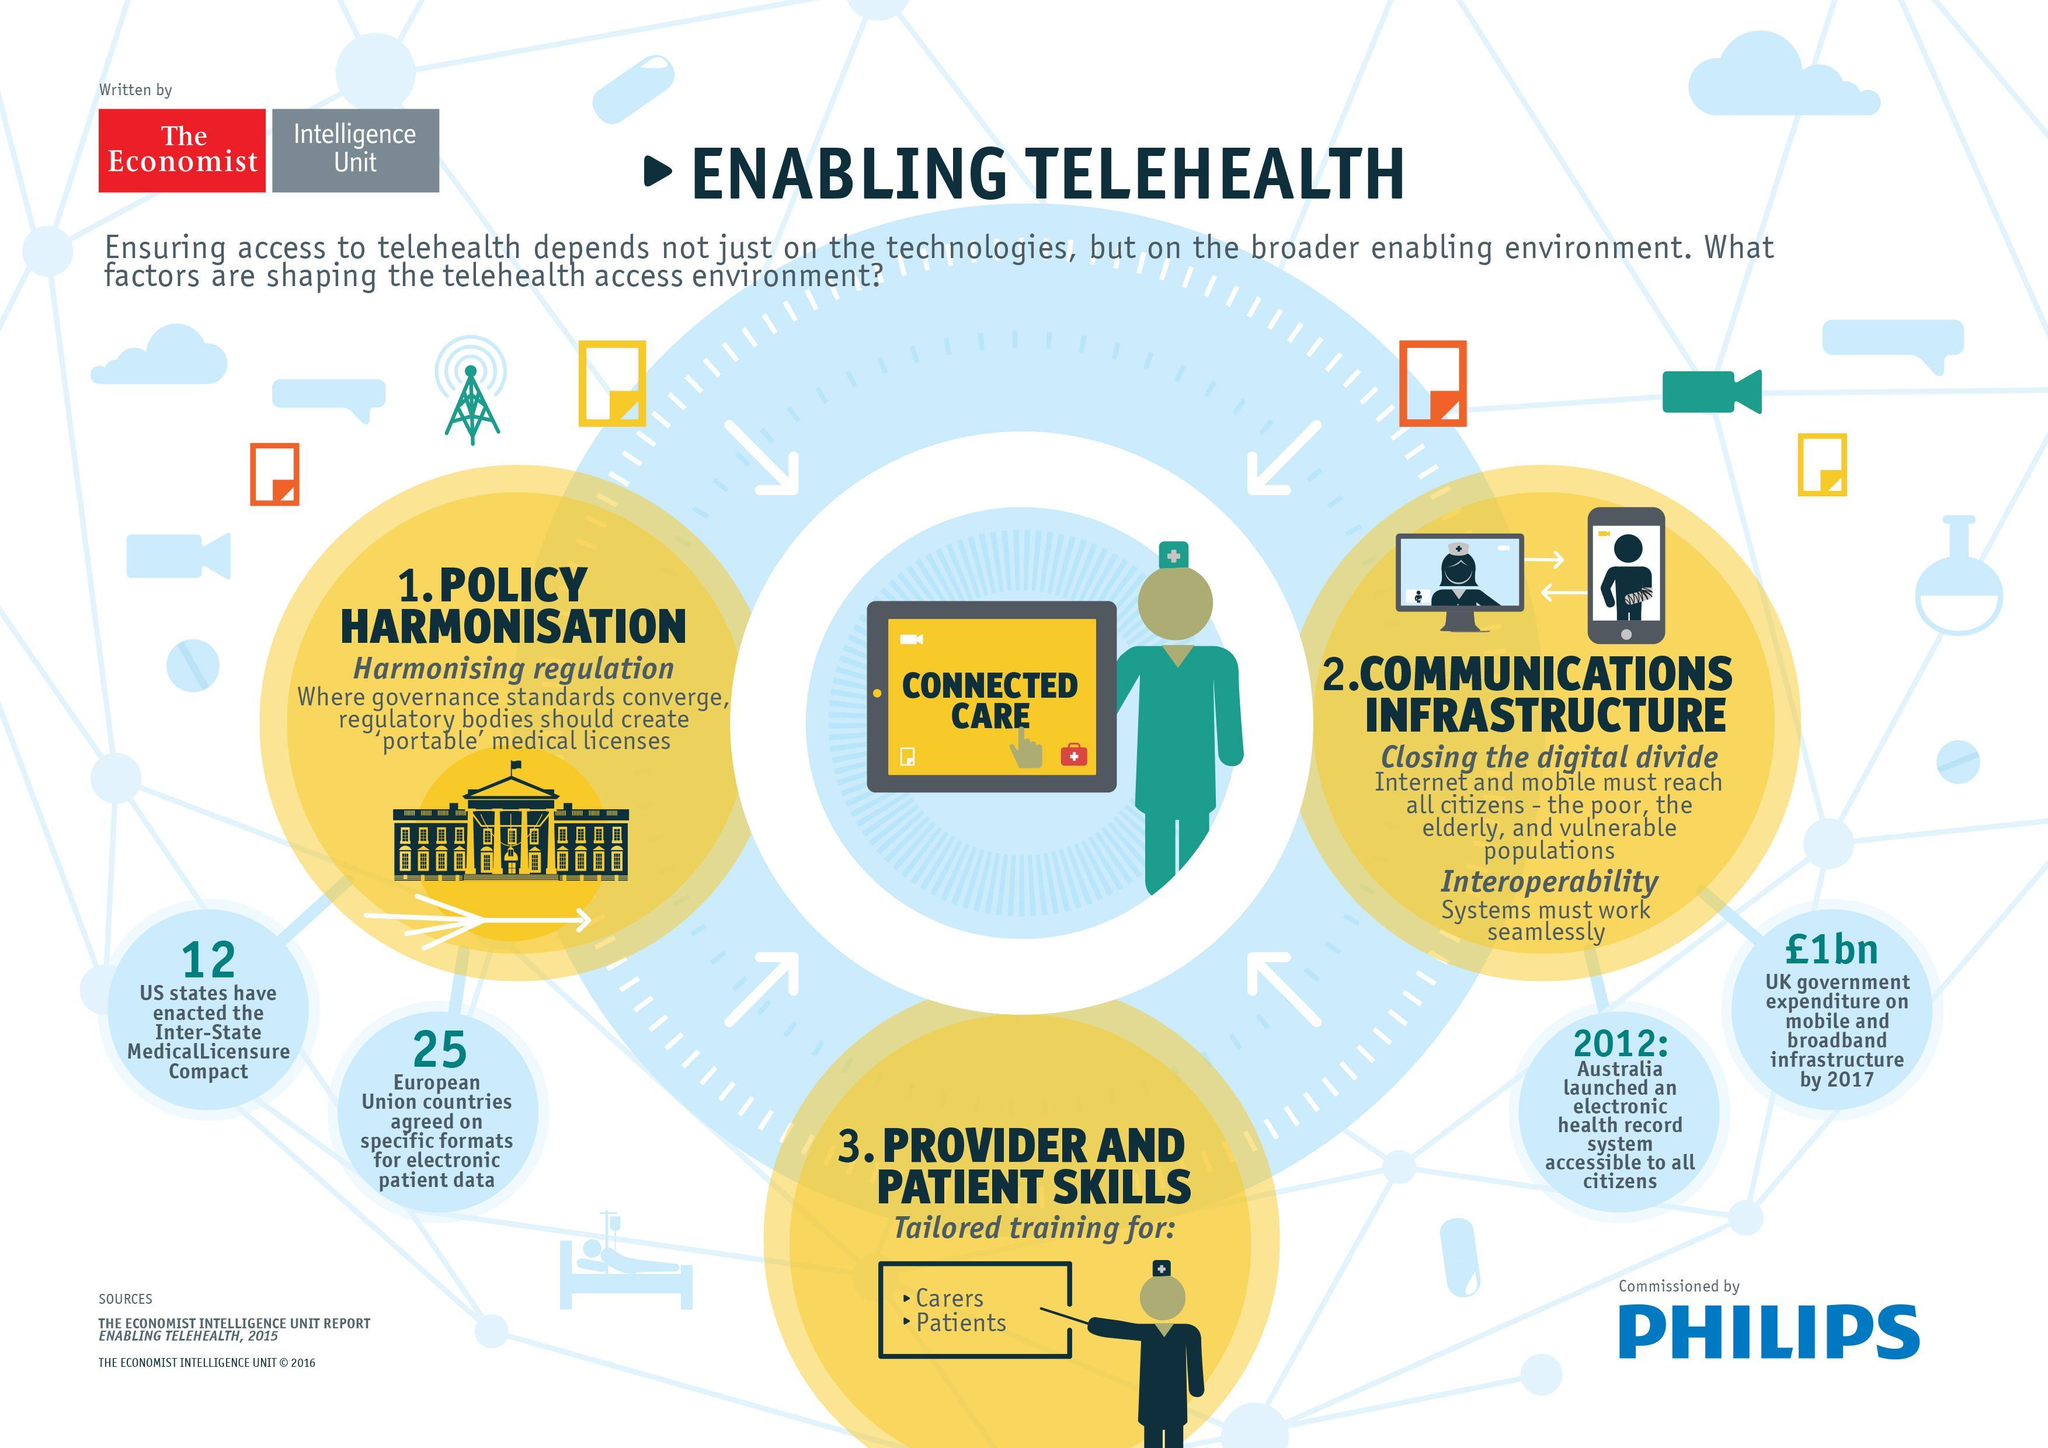How many European Union countries agreed on specific formats for electronic patient data?
Answer the question with a short phrase. 25 How many US states have enacted the Inter-State Medical Licensure compact? 12 